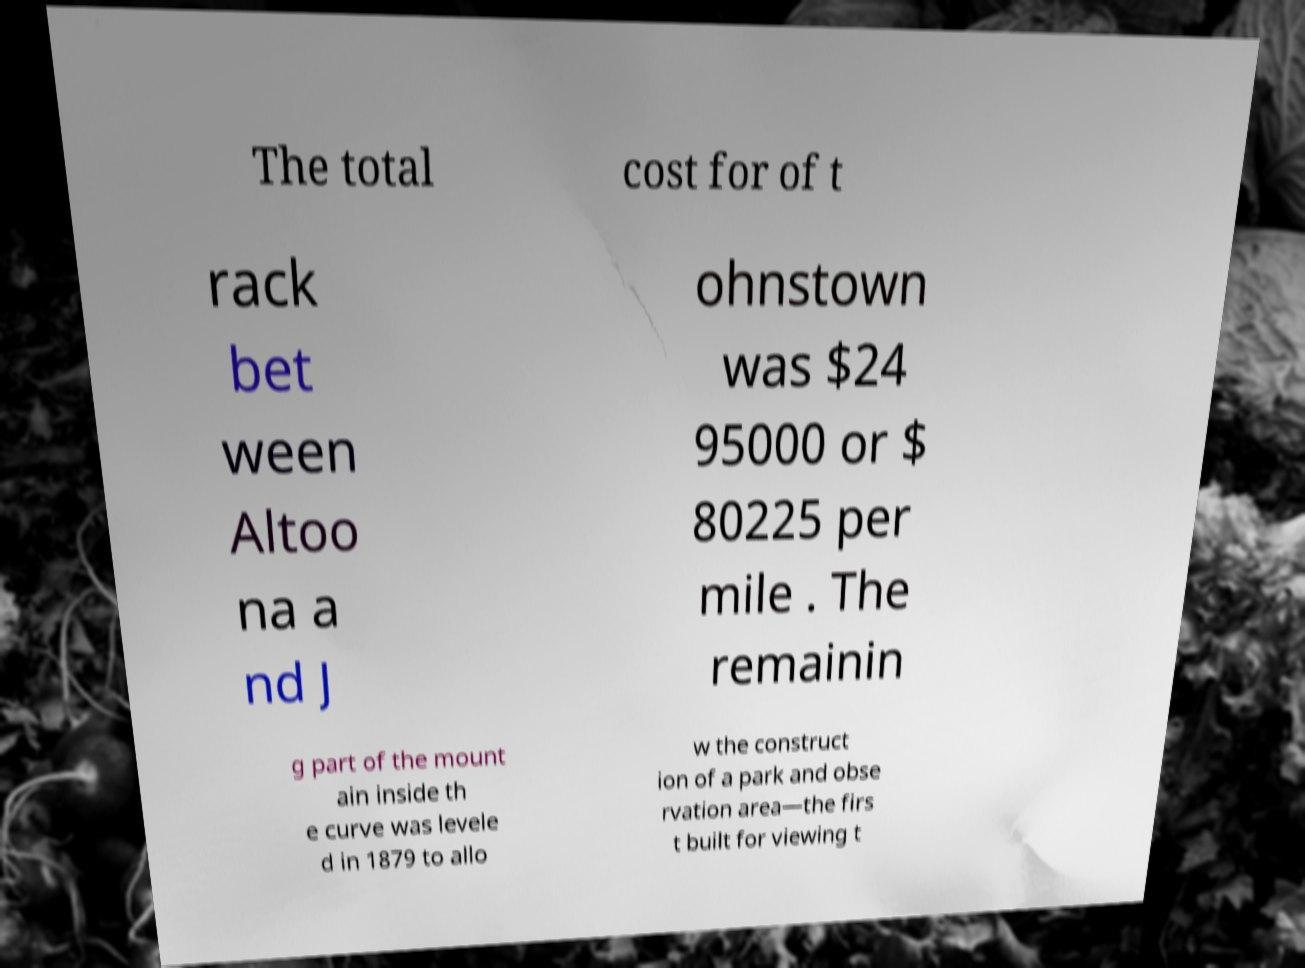Could you assist in decoding the text presented in this image and type it out clearly? The total cost for of t rack bet ween Altoo na a nd J ohnstown was $24 95000 or $ 80225 per mile . The remainin g part of the mount ain inside th e curve was levele d in 1879 to allo w the construct ion of a park and obse rvation area—the firs t built for viewing t 